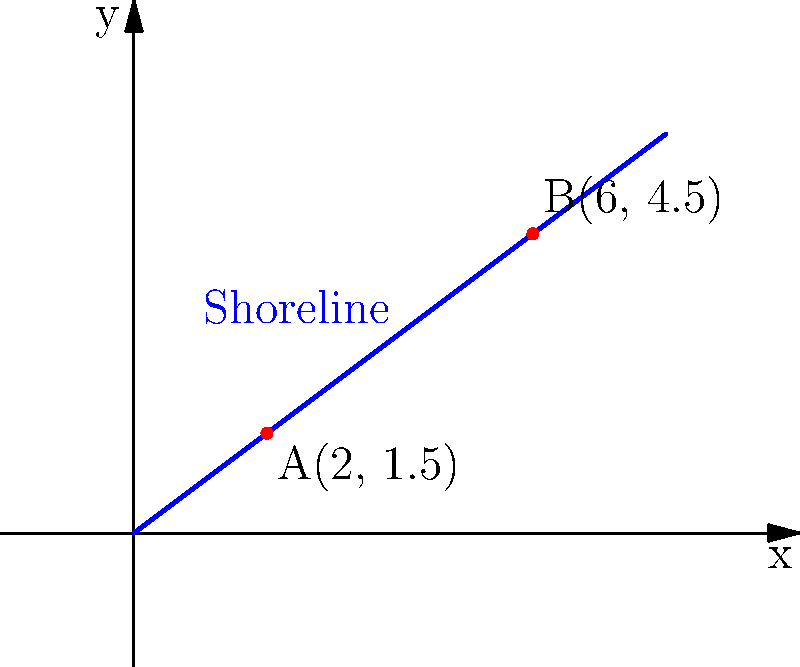As a representative of a fishing village, you're mapping out the local shoreline to better understand fishing zones. Two points along the coast have been identified: point A at (2, 1.5) and point B at (6, 4.5). Assuming the shoreline follows a straight line between these points, determine the equation of the line representing the shoreline in slope-intercept form (y = mx + b). To find the equation of the line representing the shoreline, we'll follow these steps:

1) Calculate the slope (m) using the two given points:
   $m = \frac{y_2 - y_1}{x_2 - x_1} = \frac{4.5 - 1.5}{6 - 2} = \frac{3}{4} = 0.75$

2) Use the point-slope form of a line equation:
   $y - y_1 = m(x - x_1)$

3) Let's use point A(2, 1.5). Substitute the values:
   $y - 1.5 = 0.75(x - 2)$

4) Expand the equation:
   $y - 1.5 = 0.75x - 1.5$

5) Add 1.5 to both sides to isolate y:
   $y = 0.75x - 1.5 + 1.5$

6) Simplify to get the slope-intercept form:
   $y = 0.75x$

Therefore, the equation of the shoreline is $y = 0.75x$.
Answer: $y = 0.75x$ 